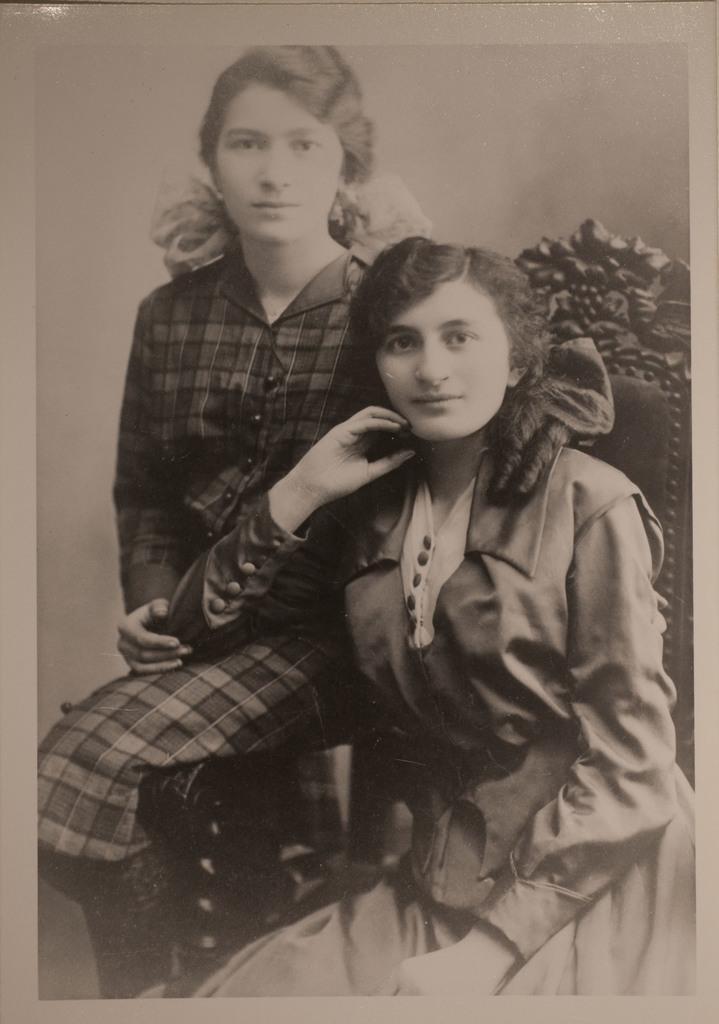In one or two sentences, can you explain what this image depicts? This is a black and white image. On the right side, there is a girl sitting on a chair and keeping her elbow on a leg of another girl who is sitting. 